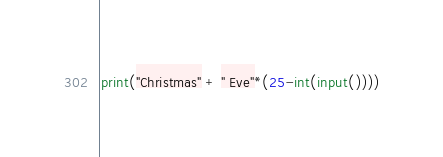<code> <loc_0><loc_0><loc_500><loc_500><_Python_>print("Christmas" + " Eve"*(25-int(input())))</code> 